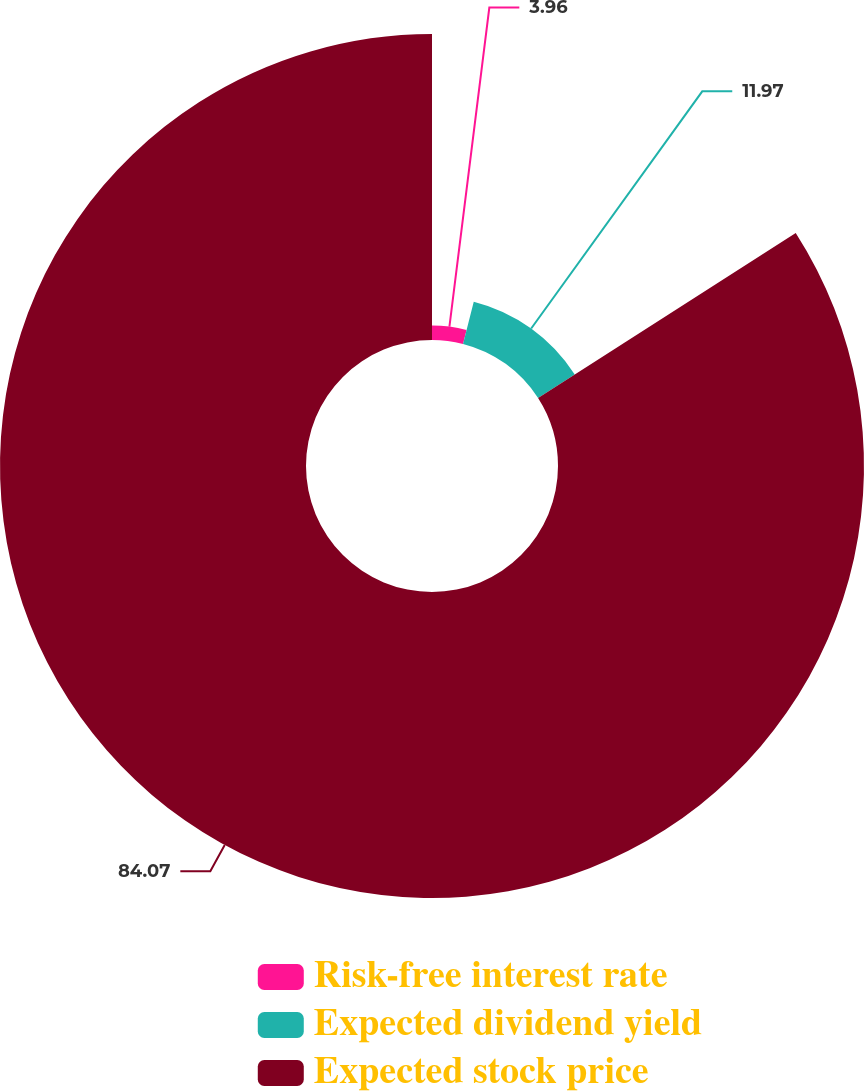Convert chart. <chart><loc_0><loc_0><loc_500><loc_500><pie_chart><fcel>Risk-free interest rate<fcel>Expected dividend yield<fcel>Expected stock price<nl><fcel>3.96%<fcel>11.97%<fcel>84.07%<nl></chart> 